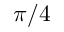Convert formula to latex. <formula><loc_0><loc_0><loc_500><loc_500>\pi / 4</formula> 